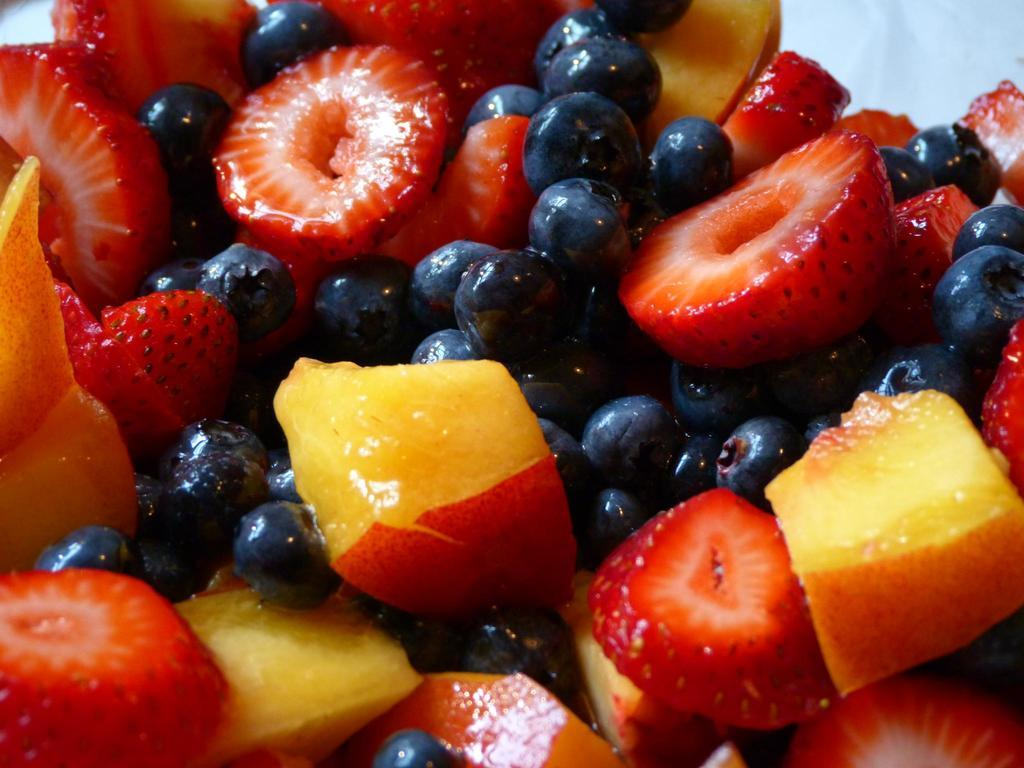What is the main subject of the image? The main subject of the image is cut fruits. Can you describe the arrangement of the fruits in the image? The cut fruits are in the center of the image. What is the chance of the fruits pulling themselves together in the image? There is no indication in the image that the fruits have the ability to move or pull themselves together. 